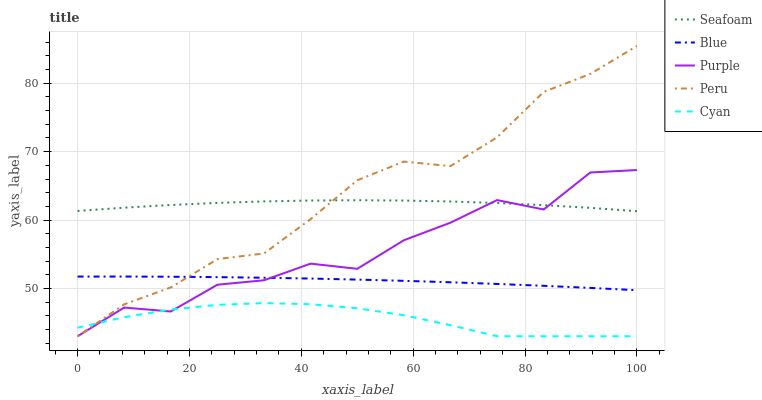Does Cyan have the minimum area under the curve?
Answer yes or no. Yes. Does Peru have the maximum area under the curve?
Answer yes or no. Yes. Does Purple have the minimum area under the curve?
Answer yes or no. No. Does Purple have the maximum area under the curve?
Answer yes or no. No. Is Blue the smoothest?
Answer yes or no. Yes. Is Purple the roughest?
Answer yes or no. Yes. Is Seafoam the smoothest?
Answer yes or no. No. Is Seafoam the roughest?
Answer yes or no. No. Does Seafoam have the lowest value?
Answer yes or no. No. Does Peru have the highest value?
Answer yes or no. Yes. Does Purple have the highest value?
Answer yes or no. No. Is Cyan less than Seafoam?
Answer yes or no. Yes. Is Blue greater than Cyan?
Answer yes or no. Yes. Does Peru intersect Seafoam?
Answer yes or no. Yes. Is Peru less than Seafoam?
Answer yes or no. No. Is Peru greater than Seafoam?
Answer yes or no. No. Does Cyan intersect Seafoam?
Answer yes or no. No. 